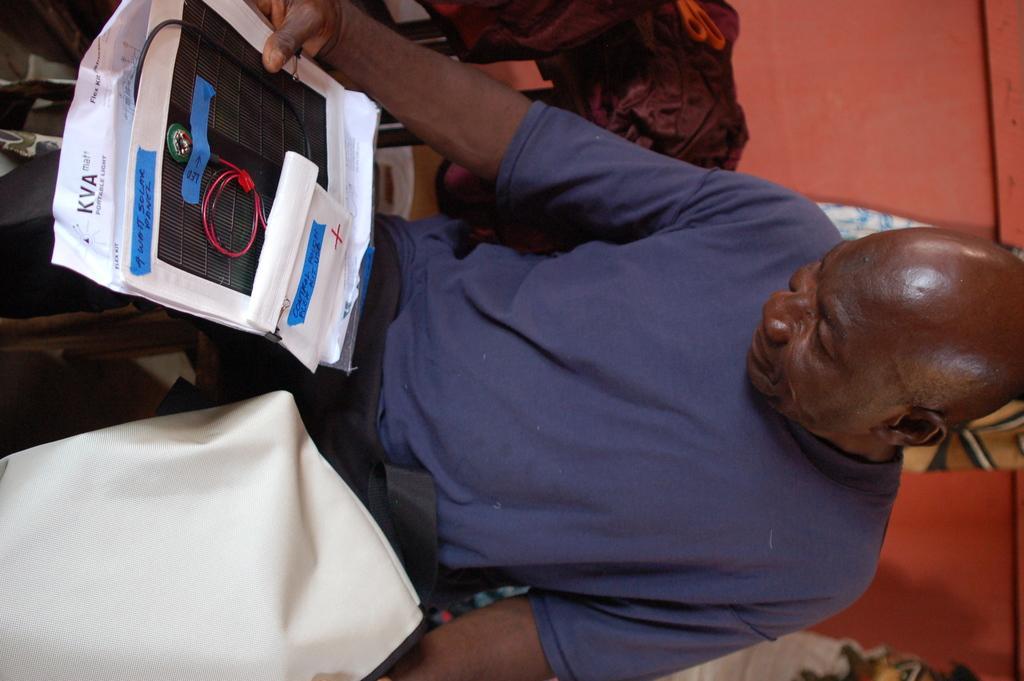Could you give a brief overview of what you see in this image? In the foreground of this image, there is a man sitting on the chair, holding few medical report papers and it seems like a cloth in another hand. In the background, there are clothes and the wall. 